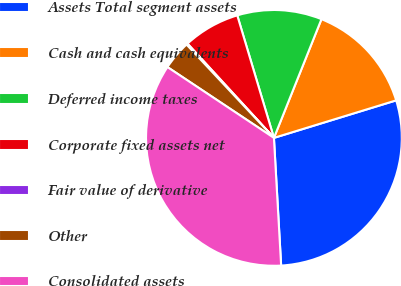<chart> <loc_0><loc_0><loc_500><loc_500><pie_chart><fcel>Assets Total segment assets<fcel>Cash and cash equivalents<fcel>Deferred income taxes<fcel>Corporate fixed assets net<fcel>Fair value of derivative<fcel>Other<fcel>Consolidated assets<nl><fcel>28.84%<fcel>14.2%<fcel>10.69%<fcel>7.18%<fcel>0.17%<fcel>3.68%<fcel>35.24%<nl></chart> 